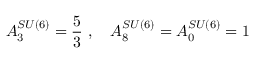Convert formula to latex. <formula><loc_0><loc_0><loc_500><loc_500>A _ { 3 } ^ { S U ( 6 ) } = \frac { 5 } { 3 } \, , \quad A _ { 8 } ^ { S U ( 6 ) } = A _ { 0 } ^ { S U ( 6 ) } = 1</formula> 